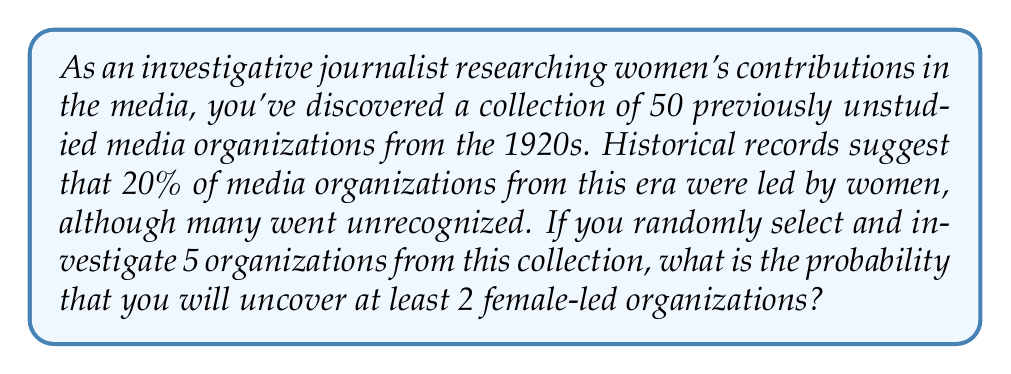Can you solve this math problem? To solve this problem, we'll use the binomial probability distribution.

Let's define our variables:
$n = 5$ (number of organizations investigated)
$p = 0.20$ (probability of an organization being female-led)
$q = 1 - p = 0.80$ (probability of an organization not being female-led)

We want to find the probability of uncovering at least 2 female-led organizations. This is equivalent to the probability of uncovering 2, 3, 4, or 5 female-led organizations.

We can calculate this using the following steps:

1. Calculate the probability of exactly 2, 3, 4, and 5 successes using the binomial probability formula:

   $$P(X = k) = \binom{n}{k} p^k q^{n-k}$$

2. Sum these probabilities to get the probability of at least 2 successes.

Calculations:

P(X = 2): $\binom{5}{2} (0.20)^2 (0.80)^3 = 10 \times 0.04 \times 0.512 = 0.2048$

P(X = 3): $\binom{5}{3} (0.20)^3 (0.80)^2 = 10 \times 0.008 \times 0.64 = 0.0512$

P(X = 4): $\binom{5}{4} (0.20)^4 (0.80)^1 = 5 \times 0.0016 \times 0.80 = 0.0064$

P(X = 5): $\binom{5}{5} (0.20)^5 (0.80)^0 = 1 \times 0.00032 \times 1 = 0.00032$

Now, we sum these probabilities:

P(X ≥ 2) = 0.2048 + 0.0512 + 0.0064 + 0.00032 = 0.26272
Answer: The probability of uncovering at least 2 female-led organizations is approximately 0.2627 or 26.27%. 